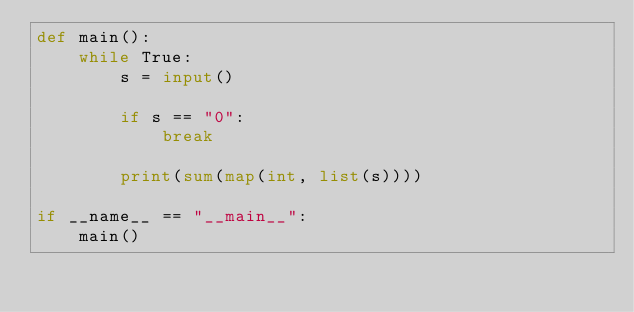<code> <loc_0><loc_0><loc_500><loc_500><_Python_>def main():
    while True:
        s = input()

        if s == "0":
            break

        print(sum(map(int, list(s))))

if __name__ == "__main__":
    main()</code> 